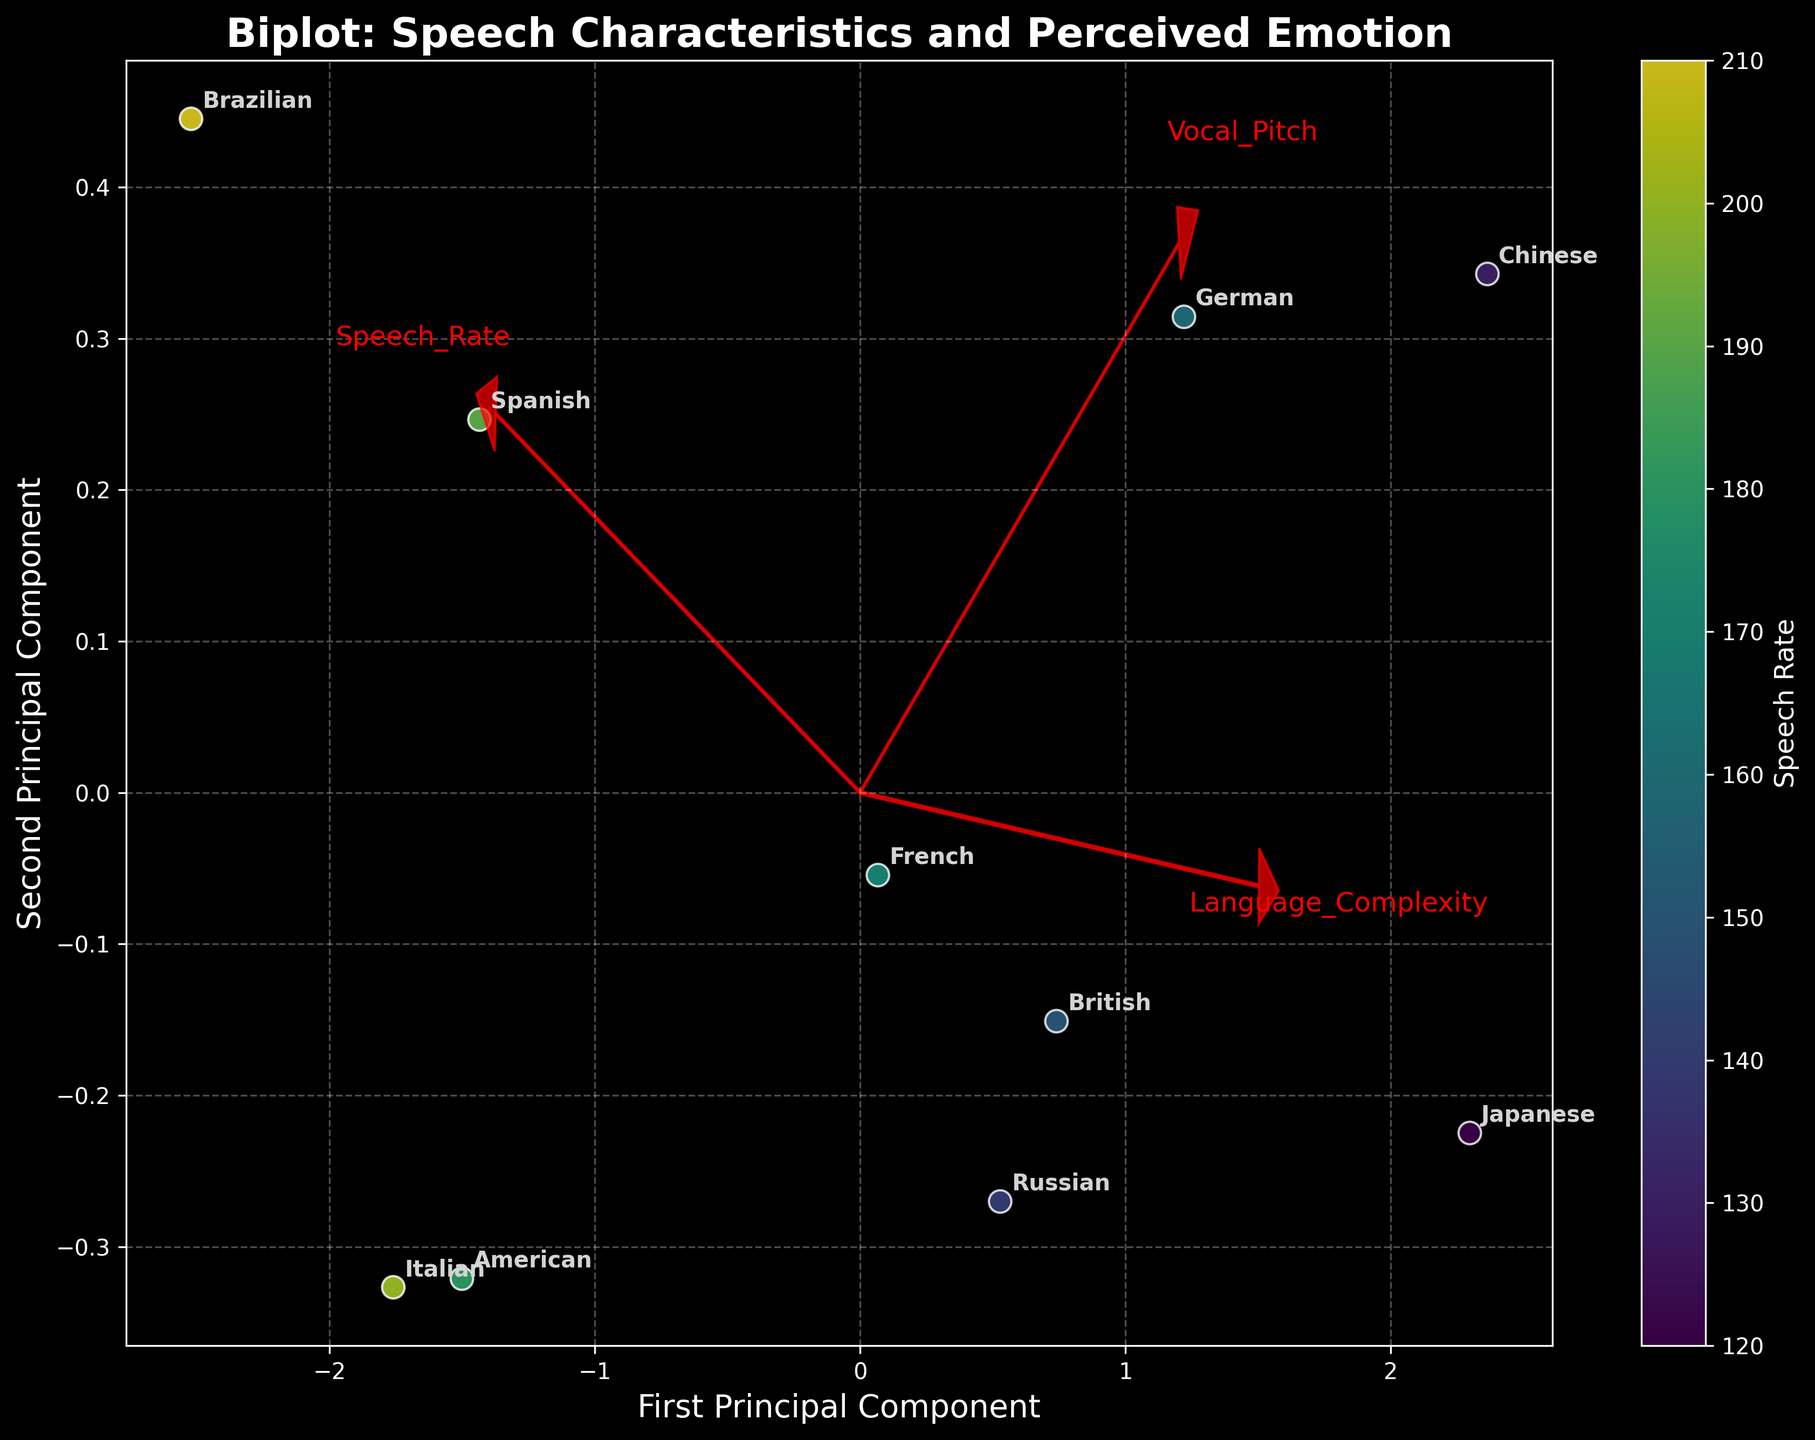Which culture exhibits the highest speech rate? Look for the culture with the data point having the highest color value on the color scale. It is Brazilian, with a speech rate of 210.
Answer: Brazilian What is the relationship between 'Speech_Rate' and the first principal component? By observing the direction of the 'Speech_Rate' vector, you can see it points mostly along the first principal component, indicating a strong positive correlation.
Answer: Strong positive correlation Which cultures show similar perceived emotions based on proximity in the biplot? Cultures that cluster together in the plot likely have similar perceived emotions. For example, American (Excitement) and Italian (Passion) appear close to each other.
Answer: American and Italian What can be inferred about the Speech_Rate for cultures positioned on the far right of the plot? Cultures on the far right have higher speech rates as indicated by the gradient of the color scale and the position of the 'Speech_Rate' vector.
Answer: Higher speech rates Compare the 'Speech_Rate' of American and Japanese cultures. Which one is higher? By comparing the color values (intensity), American has a higher 'Speech_Rate' than Japanese.
Answer: American What do the arrows represent in the biplot? The arrows represent the direction and magnitude of the original standardized features (Speech_Rate, Language_Complexity, Vocal_Pitch) in the principal component space.
Answer: Direction and magnitude of features What can be said about the perceived emotions of the cultures nearest to each other? Cultures positioned near each other likely share similar perceived emotions; for example, French (Confidence) and British (Composure) are close and suggest similar emotional expressions.
Answer: Similar perceived emotions How does Language_Complexity relate to the second principal component? The 'Language_Complexity' arrow direction indicates a positive correlation with the second principal component.
Answer: Positive correlation Do cultures with higher language complexity tend to cluster together? By observing the vector for 'Language_Complexity', cultures like Japanese, Chinese, and German with higher complexity seem to cluster together on the biplot.
Answer: Yes Is the Vocal_Pitch vector more aligned with the first or second principal component? By observing the direction of the 'Vocal_Pitch' vector, it is more aligned with the first principal component.
Answer: First principal component 